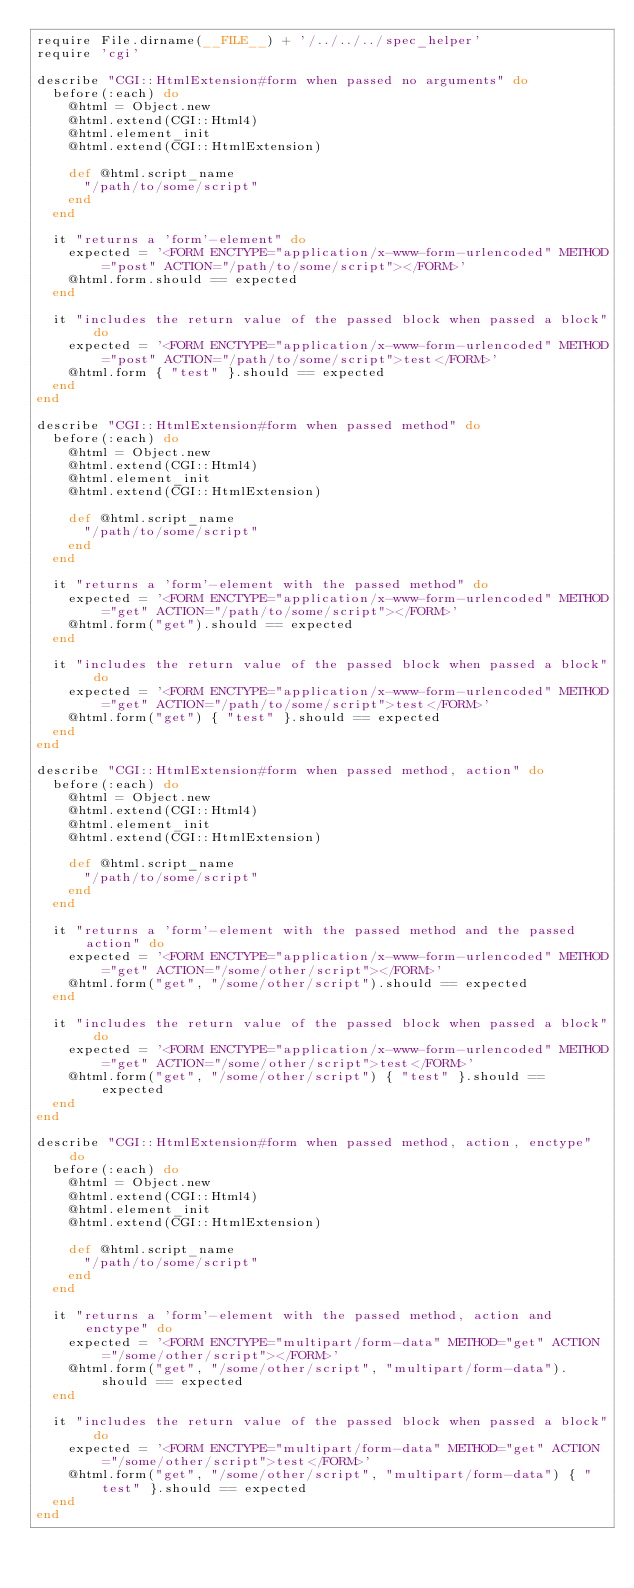<code> <loc_0><loc_0><loc_500><loc_500><_Ruby_>require File.dirname(__FILE__) + '/../../../spec_helper'
require 'cgi'

describe "CGI::HtmlExtension#form when passed no arguments" do
  before(:each) do
    @html = Object.new
    @html.extend(CGI::Html4)
    @html.element_init
    @html.extend(CGI::HtmlExtension)
    
    def @html.script_name
      "/path/to/some/script"
    end
  end
  
  it "returns a 'form'-element" do
    expected = '<FORM ENCTYPE="application/x-www-form-urlencoded" METHOD="post" ACTION="/path/to/some/script"></FORM>'
    @html.form.should == expected
  end

  it "includes the return value of the passed block when passed a block" do
    expected = '<FORM ENCTYPE="application/x-www-form-urlencoded" METHOD="post" ACTION="/path/to/some/script">test</FORM>'
    @html.form { "test" }.should == expected
  end
end

describe "CGI::HtmlExtension#form when passed method" do
  before(:each) do
    @html = Object.new
    @html.extend(CGI::Html4)
    @html.element_init
    @html.extend(CGI::HtmlExtension)
    
    def @html.script_name
      "/path/to/some/script"
    end
  end
  
  it "returns a 'form'-element with the passed method" do
    expected = '<FORM ENCTYPE="application/x-www-form-urlencoded" METHOD="get" ACTION="/path/to/some/script"></FORM>'
    @html.form("get").should == expected
  end

  it "includes the return value of the passed block when passed a block" do
    expected = '<FORM ENCTYPE="application/x-www-form-urlencoded" METHOD="get" ACTION="/path/to/some/script">test</FORM>'
    @html.form("get") { "test" }.should == expected
  end
end

describe "CGI::HtmlExtension#form when passed method, action" do
  before(:each) do
    @html = Object.new
    @html.extend(CGI::Html4)
    @html.element_init
    @html.extend(CGI::HtmlExtension)
    
    def @html.script_name
      "/path/to/some/script"
    end
  end
  
  it "returns a 'form'-element with the passed method and the passed action" do
    expected = '<FORM ENCTYPE="application/x-www-form-urlencoded" METHOD="get" ACTION="/some/other/script"></FORM>'
    @html.form("get", "/some/other/script").should == expected
  end

  it "includes the return value of the passed block when passed a block" do
    expected = '<FORM ENCTYPE="application/x-www-form-urlencoded" METHOD="get" ACTION="/some/other/script">test</FORM>'
    @html.form("get", "/some/other/script") { "test" }.should == expected
  end
end

describe "CGI::HtmlExtension#form when passed method, action, enctype" do
  before(:each) do
    @html = Object.new
    @html.extend(CGI::Html4)
    @html.element_init
    @html.extend(CGI::HtmlExtension)
    
    def @html.script_name
      "/path/to/some/script"
    end
  end
  
  it "returns a 'form'-element with the passed method, action and enctype" do
    expected = '<FORM ENCTYPE="multipart/form-data" METHOD="get" ACTION="/some/other/script"></FORM>'
    @html.form("get", "/some/other/script", "multipart/form-data").should == expected
  end
  
  it "includes the return value of the passed block when passed a block" do
    expected = '<FORM ENCTYPE="multipart/form-data" METHOD="get" ACTION="/some/other/script">test</FORM>'
    @html.form("get", "/some/other/script", "multipart/form-data") { "test" }.should == expected
  end
end</code> 